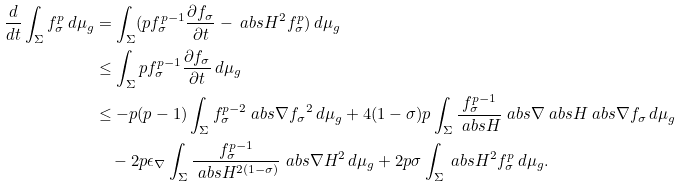<formula> <loc_0><loc_0><loc_500><loc_500>\frac { d } { d t } \int _ { \Sigma } f _ { \sigma } ^ { p } \, d \mu _ { g } & = \int _ { \Sigma } ( p f _ { \sigma } ^ { p - 1 } \frac { \partial f _ { \sigma } } { \partial t } - \ a b s { H } ^ { 2 } f _ { \sigma } ^ { p } ) \, d \mu _ { g } \\ & \leq \int _ { \Sigma } p f _ { \sigma } ^ { p - 1 } \frac { \partial f _ { \sigma } } { \partial t } \, d \mu _ { g } \\ & \leq - p ( p - 1 ) \int _ { \Sigma } f _ { \sigma } ^ { p - 2 } \ a b s { \nabla f _ { \sigma } } ^ { 2 } \, d \mu _ { g } + 4 ( 1 - \sigma ) p \int _ { \Sigma } \frac { f _ { \sigma } ^ { p - 1 } } { \ a b s { H } } \ a b s { \nabla \ a b s { H } } \ a b s { \nabla f _ { \sigma } } \, d \mu _ { g } \\ & \quad - 2 p \epsilon _ { \nabla } \int _ { \Sigma } \frac { f _ { \sigma } ^ { p - 1 } } { \ a b s { H } ^ { 2 ( 1 - \sigma ) } } \ a b s { \nabla H } ^ { 2 } \, d \mu _ { g } + 2 p \sigma \int _ { \Sigma } \ a b s { H } ^ { 2 } f _ { \sigma } ^ { p } \, d \mu _ { g } .</formula> 